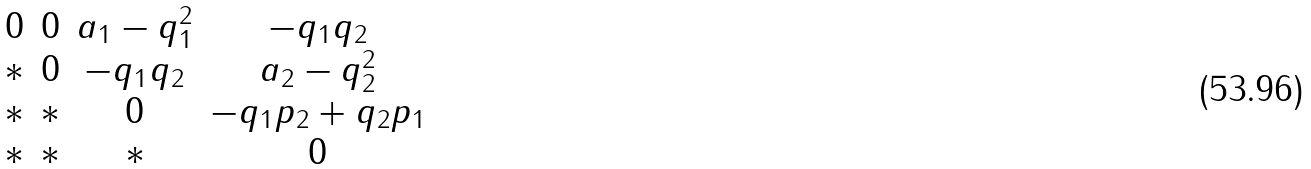<formula> <loc_0><loc_0><loc_500><loc_500>\begin{matrix} 0 & 0 & a _ { 1 } - q _ { 1 } ^ { 2 } & - q _ { 1 } q _ { 2 } \\ * & 0 & - q _ { 1 } q _ { 2 } & a _ { 2 } - q _ { 2 } ^ { 2 } \\ * & * & 0 & - q _ { 1 } p _ { 2 } + q _ { 2 } p _ { 1 } \\ * & * & * & 0 \end{matrix}</formula> 